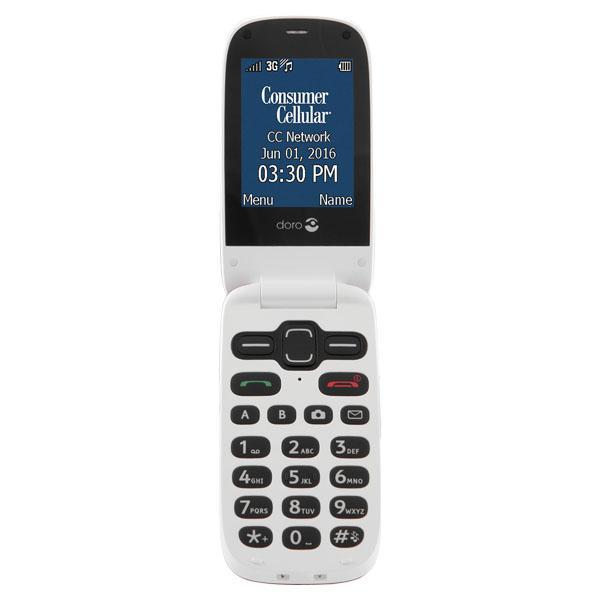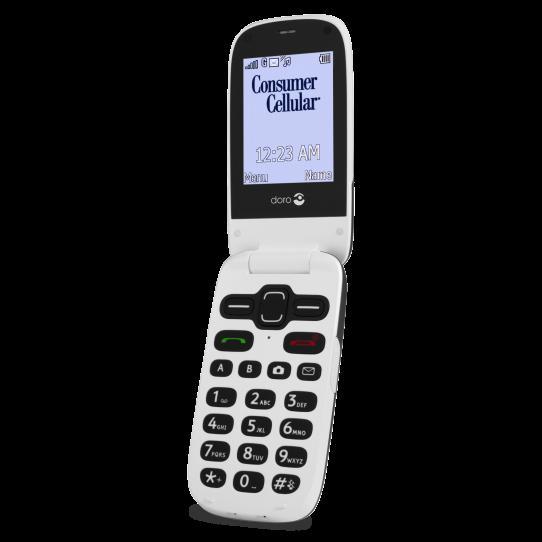The first image is the image on the left, the second image is the image on the right. Considering the images on both sides, is "Left and right images each show an open white flip phone with black buttons, rounded corners, and something displayed on the screen." valid? Answer yes or no. Yes. The first image is the image on the left, the second image is the image on the right. Given the left and right images, does the statement "The phone in each image is flipped open to reveal the screen." hold true? Answer yes or no. Yes. 